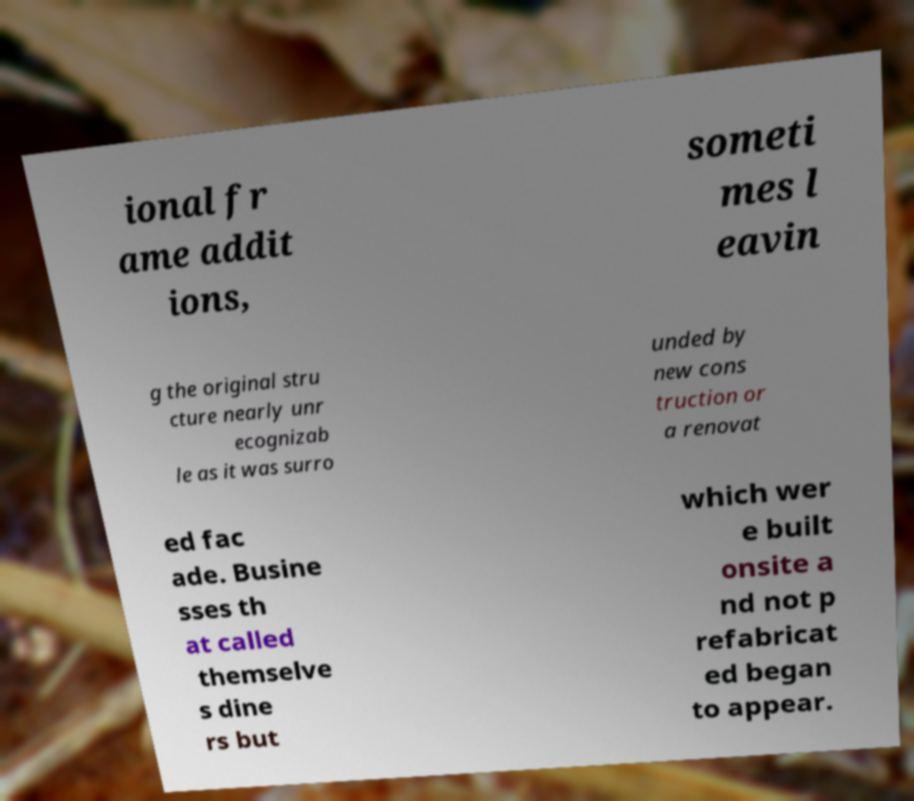There's text embedded in this image that I need extracted. Can you transcribe it verbatim? ional fr ame addit ions, someti mes l eavin g the original stru cture nearly unr ecognizab le as it was surro unded by new cons truction or a renovat ed fac ade. Busine sses th at called themselve s dine rs but which wer e built onsite a nd not p refabricat ed began to appear. 